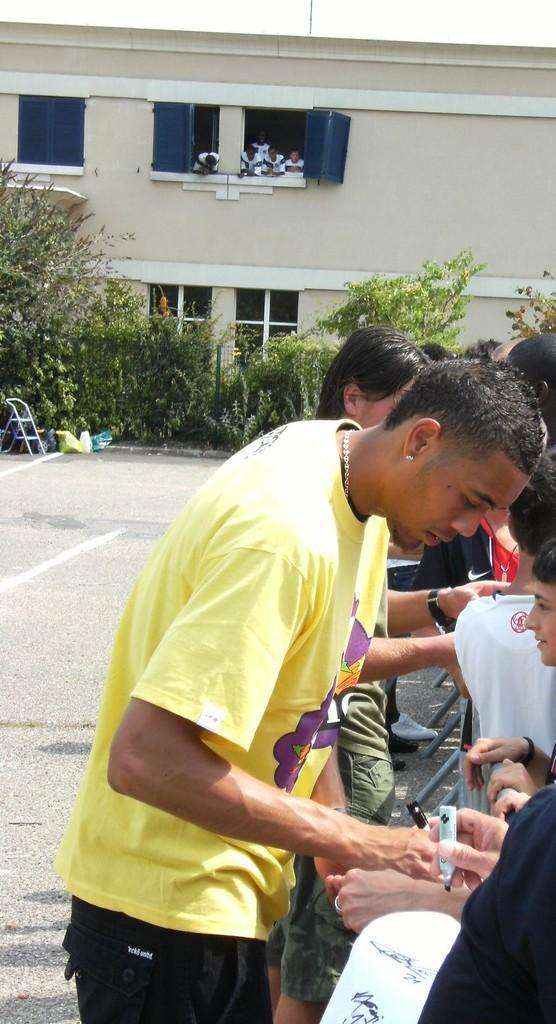In one or two sentences, can you explain what this image depicts? In the center of the image there are people standing on the road. In the background of the image there are children in the window. There is a building. There are plants. There is a chair. 